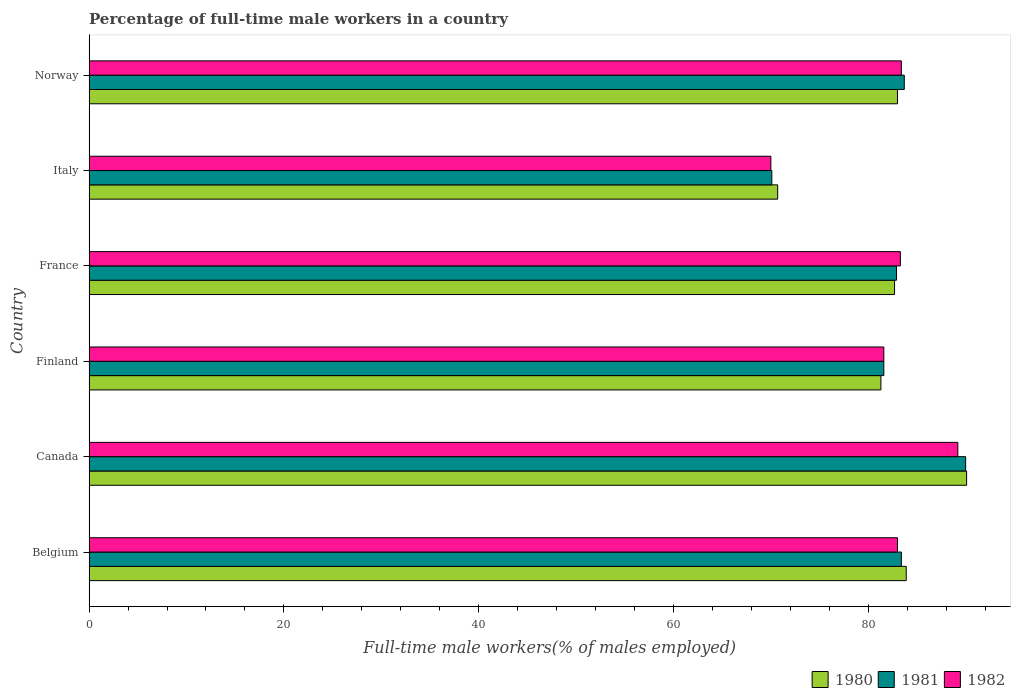How many groups of bars are there?
Give a very brief answer. 6. Are the number of bars per tick equal to the number of legend labels?
Your answer should be very brief. Yes. How many bars are there on the 2nd tick from the top?
Provide a short and direct response. 3. How many bars are there on the 2nd tick from the bottom?
Your response must be concise. 3. What is the label of the 6th group of bars from the top?
Provide a succinct answer. Belgium. What is the percentage of full-time male workers in 1981 in Belgium?
Ensure brevity in your answer.  83.4. Across all countries, what is the maximum percentage of full-time male workers in 1982?
Provide a succinct answer. 89.2. Across all countries, what is the minimum percentage of full-time male workers in 1981?
Your answer should be very brief. 70.1. In which country was the percentage of full-time male workers in 1981 maximum?
Offer a very short reply. Canada. In which country was the percentage of full-time male workers in 1981 minimum?
Provide a short and direct response. Italy. What is the total percentage of full-time male workers in 1980 in the graph?
Provide a succinct answer. 491.7. What is the difference between the percentage of full-time male workers in 1982 in Italy and the percentage of full-time male workers in 1981 in Norway?
Offer a very short reply. -13.7. What is the average percentage of full-time male workers in 1982 per country?
Your answer should be very brief. 81.75. What is the difference between the percentage of full-time male workers in 1980 and percentage of full-time male workers in 1982 in Norway?
Ensure brevity in your answer.  -0.4. What is the ratio of the percentage of full-time male workers in 1982 in Belgium to that in Italy?
Your answer should be compact. 1.19. Is the percentage of full-time male workers in 1980 in Finland less than that in Italy?
Keep it short and to the point. No. Is the difference between the percentage of full-time male workers in 1980 in Canada and France greater than the difference between the percentage of full-time male workers in 1982 in Canada and France?
Make the answer very short. Yes. What is the difference between the highest and the second highest percentage of full-time male workers in 1980?
Provide a short and direct response. 6.2. What is the difference between the highest and the lowest percentage of full-time male workers in 1980?
Provide a succinct answer. 19.4. Is the sum of the percentage of full-time male workers in 1982 in Belgium and Finland greater than the maximum percentage of full-time male workers in 1980 across all countries?
Provide a short and direct response. Yes. What does the 1st bar from the top in Italy represents?
Provide a succinct answer. 1982. Is it the case that in every country, the sum of the percentage of full-time male workers in 1980 and percentage of full-time male workers in 1982 is greater than the percentage of full-time male workers in 1981?
Your answer should be very brief. Yes. How many bars are there?
Provide a short and direct response. 18. What is the difference between two consecutive major ticks on the X-axis?
Ensure brevity in your answer.  20. How many legend labels are there?
Your response must be concise. 3. What is the title of the graph?
Keep it short and to the point. Percentage of full-time male workers in a country. What is the label or title of the X-axis?
Your response must be concise. Full-time male workers(% of males employed). What is the Full-time male workers(% of males employed) in 1980 in Belgium?
Ensure brevity in your answer.  83.9. What is the Full-time male workers(% of males employed) of 1981 in Belgium?
Your answer should be very brief. 83.4. What is the Full-time male workers(% of males employed) of 1980 in Canada?
Keep it short and to the point. 90.1. What is the Full-time male workers(% of males employed) of 1982 in Canada?
Keep it short and to the point. 89.2. What is the Full-time male workers(% of males employed) in 1980 in Finland?
Provide a succinct answer. 81.3. What is the Full-time male workers(% of males employed) in 1981 in Finland?
Ensure brevity in your answer.  81.6. What is the Full-time male workers(% of males employed) in 1982 in Finland?
Your answer should be compact. 81.6. What is the Full-time male workers(% of males employed) in 1980 in France?
Ensure brevity in your answer.  82.7. What is the Full-time male workers(% of males employed) of 1981 in France?
Offer a terse response. 82.9. What is the Full-time male workers(% of males employed) in 1982 in France?
Your answer should be compact. 83.3. What is the Full-time male workers(% of males employed) of 1980 in Italy?
Give a very brief answer. 70.7. What is the Full-time male workers(% of males employed) of 1981 in Italy?
Make the answer very short. 70.1. What is the Full-time male workers(% of males employed) in 1982 in Italy?
Provide a short and direct response. 70. What is the Full-time male workers(% of males employed) of 1980 in Norway?
Give a very brief answer. 83. What is the Full-time male workers(% of males employed) of 1981 in Norway?
Provide a short and direct response. 83.7. What is the Full-time male workers(% of males employed) of 1982 in Norway?
Provide a short and direct response. 83.4. Across all countries, what is the maximum Full-time male workers(% of males employed) of 1980?
Your response must be concise. 90.1. Across all countries, what is the maximum Full-time male workers(% of males employed) in 1981?
Offer a very short reply. 90. Across all countries, what is the maximum Full-time male workers(% of males employed) of 1982?
Ensure brevity in your answer.  89.2. Across all countries, what is the minimum Full-time male workers(% of males employed) in 1980?
Keep it short and to the point. 70.7. Across all countries, what is the minimum Full-time male workers(% of males employed) of 1981?
Provide a short and direct response. 70.1. Across all countries, what is the minimum Full-time male workers(% of males employed) in 1982?
Your answer should be compact. 70. What is the total Full-time male workers(% of males employed) in 1980 in the graph?
Your answer should be compact. 491.7. What is the total Full-time male workers(% of males employed) of 1981 in the graph?
Give a very brief answer. 491.7. What is the total Full-time male workers(% of males employed) of 1982 in the graph?
Provide a succinct answer. 490.5. What is the difference between the Full-time male workers(% of males employed) in 1981 in Belgium and that in Canada?
Provide a succinct answer. -6.6. What is the difference between the Full-time male workers(% of males employed) of 1982 in Belgium and that in Canada?
Your answer should be compact. -6.2. What is the difference between the Full-time male workers(% of males employed) of 1981 in Belgium and that in Finland?
Your answer should be very brief. 1.8. What is the difference between the Full-time male workers(% of males employed) in 1982 in Belgium and that in Finland?
Offer a terse response. 1.4. What is the difference between the Full-time male workers(% of males employed) in 1981 in Belgium and that in France?
Ensure brevity in your answer.  0.5. What is the difference between the Full-time male workers(% of males employed) of 1981 in Belgium and that in Italy?
Keep it short and to the point. 13.3. What is the difference between the Full-time male workers(% of males employed) in 1982 in Belgium and that in Italy?
Your answer should be very brief. 13. What is the difference between the Full-time male workers(% of males employed) in 1980 in Belgium and that in Norway?
Keep it short and to the point. 0.9. What is the difference between the Full-time male workers(% of males employed) of 1981 in Belgium and that in Norway?
Keep it short and to the point. -0.3. What is the difference between the Full-time male workers(% of males employed) of 1982 in Belgium and that in Norway?
Your response must be concise. -0.4. What is the difference between the Full-time male workers(% of males employed) in 1981 in Canada and that in Finland?
Provide a short and direct response. 8.4. What is the difference between the Full-time male workers(% of males employed) in 1981 in Canada and that in France?
Provide a succinct answer. 7.1. What is the difference between the Full-time male workers(% of males employed) of 1980 in Canada and that in Italy?
Your answer should be compact. 19.4. What is the difference between the Full-time male workers(% of males employed) of 1981 in Canada and that in Italy?
Your answer should be compact. 19.9. What is the difference between the Full-time male workers(% of males employed) of 1980 in Canada and that in Norway?
Offer a terse response. 7.1. What is the difference between the Full-time male workers(% of males employed) in 1982 in Canada and that in Norway?
Provide a succinct answer. 5.8. What is the difference between the Full-time male workers(% of males employed) in 1981 in Finland and that in France?
Your answer should be compact. -1.3. What is the difference between the Full-time male workers(% of males employed) of 1982 in Finland and that in France?
Keep it short and to the point. -1.7. What is the difference between the Full-time male workers(% of males employed) in 1981 in Finland and that in Italy?
Offer a very short reply. 11.5. What is the difference between the Full-time male workers(% of males employed) of 1980 in Finland and that in Norway?
Your answer should be very brief. -1.7. What is the difference between the Full-time male workers(% of males employed) in 1982 in Finland and that in Norway?
Your response must be concise. -1.8. What is the difference between the Full-time male workers(% of males employed) of 1980 in France and that in Italy?
Make the answer very short. 12. What is the difference between the Full-time male workers(% of males employed) of 1980 in France and that in Norway?
Offer a very short reply. -0.3. What is the difference between the Full-time male workers(% of males employed) in 1981 in France and that in Norway?
Your answer should be very brief. -0.8. What is the difference between the Full-time male workers(% of males employed) in 1982 in France and that in Norway?
Give a very brief answer. -0.1. What is the difference between the Full-time male workers(% of males employed) of 1980 in Italy and that in Norway?
Offer a very short reply. -12.3. What is the difference between the Full-time male workers(% of males employed) of 1981 in Italy and that in Norway?
Offer a very short reply. -13.6. What is the difference between the Full-time male workers(% of males employed) in 1980 in Belgium and the Full-time male workers(% of males employed) in 1981 in Finland?
Your answer should be compact. 2.3. What is the difference between the Full-time male workers(% of males employed) in 1980 in Belgium and the Full-time male workers(% of males employed) in 1982 in Finland?
Your answer should be compact. 2.3. What is the difference between the Full-time male workers(% of males employed) of 1981 in Belgium and the Full-time male workers(% of males employed) of 1982 in Finland?
Your answer should be compact. 1.8. What is the difference between the Full-time male workers(% of males employed) of 1980 in Belgium and the Full-time male workers(% of males employed) of 1982 in France?
Provide a succinct answer. 0.6. What is the difference between the Full-time male workers(% of males employed) of 1981 in Belgium and the Full-time male workers(% of males employed) of 1982 in France?
Your response must be concise. 0.1. What is the difference between the Full-time male workers(% of males employed) in 1980 in Canada and the Full-time male workers(% of males employed) in 1981 in Finland?
Your response must be concise. 8.5. What is the difference between the Full-time male workers(% of males employed) in 1980 in Canada and the Full-time male workers(% of males employed) in 1982 in France?
Offer a terse response. 6.8. What is the difference between the Full-time male workers(% of males employed) in 1980 in Canada and the Full-time male workers(% of males employed) in 1982 in Italy?
Provide a succinct answer. 20.1. What is the difference between the Full-time male workers(% of males employed) in 1980 in Canada and the Full-time male workers(% of males employed) in 1981 in Norway?
Your response must be concise. 6.4. What is the difference between the Full-time male workers(% of males employed) in 1980 in Canada and the Full-time male workers(% of males employed) in 1982 in Norway?
Your response must be concise. 6.7. What is the difference between the Full-time male workers(% of males employed) in 1981 in Canada and the Full-time male workers(% of males employed) in 1982 in Norway?
Your response must be concise. 6.6. What is the difference between the Full-time male workers(% of males employed) of 1980 in Finland and the Full-time male workers(% of males employed) of 1981 in France?
Offer a terse response. -1.6. What is the difference between the Full-time male workers(% of males employed) of 1980 in Finland and the Full-time male workers(% of males employed) of 1982 in France?
Give a very brief answer. -2. What is the difference between the Full-time male workers(% of males employed) of 1980 in Finland and the Full-time male workers(% of males employed) of 1981 in Italy?
Your answer should be very brief. 11.2. What is the difference between the Full-time male workers(% of males employed) of 1980 in Finland and the Full-time male workers(% of males employed) of 1982 in Norway?
Offer a terse response. -2.1. What is the difference between the Full-time male workers(% of males employed) in 1981 in Finland and the Full-time male workers(% of males employed) in 1982 in Norway?
Provide a succinct answer. -1.8. What is the difference between the Full-time male workers(% of males employed) of 1980 in France and the Full-time male workers(% of males employed) of 1981 in Italy?
Provide a short and direct response. 12.6. What is the difference between the Full-time male workers(% of males employed) in 1980 in France and the Full-time male workers(% of males employed) in 1982 in Italy?
Provide a succinct answer. 12.7. What is the difference between the Full-time male workers(% of males employed) of 1981 in France and the Full-time male workers(% of males employed) of 1982 in Italy?
Your answer should be compact. 12.9. What is the difference between the Full-time male workers(% of males employed) of 1980 in France and the Full-time male workers(% of males employed) of 1982 in Norway?
Offer a terse response. -0.7. What is the difference between the Full-time male workers(% of males employed) of 1981 in France and the Full-time male workers(% of males employed) of 1982 in Norway?
Offer a very short reply. -0.5. What is the difference between the Full-time male workers(% of males employed) of 1980 in Italy and the Full-time male workers(% of males employed) of 1981 in Norway?
Ensure brevity in your answer.  -13. What is the difference between the Full-time male workers(% of males employed) in 1980 in Italy and the Full-time male workers(% of males employed) in 1982 in Norway?
Your response must be concise. -12.7. What is the average Full-time male workers(% of males employed) of 1980 per country?
Make the answer very short. 81.95. What is the average Full-time male workers(% of males employed) of 1981 per country?
Provide a short and direct response. 81.95. What is the average Full-time male workers(% of males employed) of 1982 per country?
Your answer should be very brief. 81.75. What is the difference between the Full-time male workers(% of males employed) of 1980 and Full-time male workers(% of males employed) of 1981 in Belgium?
Offer a very short reply. 0.5. What is the difference between the Full-time male workers(% of males employed) of 1980 and Full-time male workers(% of males employed) of 1982 in Belgium?
Provide a short and direct response. 0.9. What is the difference between the Full-time male workers(% of males employed) of 1980 and Full-time male workers(% of males employed) of 1981 in Canada?
Provide a short and direct response. 0.1. What is the difference between the Full-time male workers(% of males employed) in 1981 and Full-time male workers(% of males employed) in 1982 in Canada?
Provide a short and direct response. 0.8. What is the difference between the Full-time male workers(% of males employed) of 1980 and Full-time male workers(% of males employed) of 1982 in Finland?
Give a very brief answer. -0.3. What is the difference between the Full-time male workers(% of males employed) in 1981 and Full-time male workers(% of males employed) in 1982 in Finland?
Offer a terse response. 0. What is the difference between the Full-time male workers(% of males employed) in 1980 and Full-time male workers(% of males employed) in 1981 in Italy?
Provide a succinct answer. 0.6. What is the difference between the Full-time male workers(% of males employed) in 1980 and Full-time male workers(% of males employed) in 1981 in Norway?
Keep it short and to the point. -0.7. What is the difference between the Full-time male workers(% of males employed) in 1980 and Full-time male workers(% of males employed) in 1982 in Norway?
Provide a short and direct response. -0.4. What is the difference between the Full-time male workers(% of males employed) in 1981 and Full-time male workers(% of males employed) in 1982 in Norway?
Your answer should be very brief. 0.3. What is the ratio of the Full-time male workers(% of males employed) of 1980 in Belgium to that in Canada?
Make the answer very short. 0.93. What is the ratio of the Full-time male workers(% of males employed) of 1981 in Belgium to that in Canada?
Offer a terse response. 0.93. What is the ratio of the Full-time male workers(% of males employed) of 1982 in Belgium to that in Canada?
Provide a succinct answer. 0.93. What is the ratio of the Full-time male workers(% of males employed) in 1980 in Belgium to that in Finland?
Offer a terse response. 1.03. What is the ratio of the Full-time male workers(% of males employed) in 1981 in Belgium to that in Finland?
Your answer should be very brief. 1.02. What is the ratio of the Full-time male workers(% of males employed) of 1982 in Belgium to that in Finland?
Give a very brief answer. 1.02. What is the ratio of the Full-time male workers(% of males employed) in 1980 in Belgium to that in France?
Your answer should be compact. 1.01. What is the ratio of the Full-time male workers(% of males employed) in 1981 in Belgium to that in France?
Your answer should be compact. 1.01. What is the ratio of the Full-time male workers(% of males employed) of 1980 in Belgium to that in Italy?
Offer a very short reply. 1.19. What is the ratio of the Full-time male workers(% of males employed) in 1981 in Belgium to that in Italy?
Provide a succinct answer. 1.19. What is the ratio of the Full-time male workers(% of males employed) of 1982 in Belgium to that in Italy?
Give a very brief answer. 1.19. What is the ratio of the Full-time male workers(% of males employed) in 1980 in Belgium to that in Norway?
Your answer should be very brief. 1.01. What is the ratio of the Full-time male workers(% of males employed) in 1980 in Canada to that in Finland?
Keep it short and to the point. 1.11. What is the ratio of the Full-time male workers(% of males employed) in 1981 in Canada to that in Finland?
Give a very brief answer. 1.1. What is the ratio of the Full-time male workers(% of males employed) in 1982 in Canada to that in Finland?
Provide a short and direct response. 1.09. What is the ratio of the Full-time male workers(% of males employed) of 1980 in Canada to that in France?
Keep it short and to the point. 1.09. What is the ratio of the Full-time male workers(% of males employed) in 1981 in Canada to that in France?
Offer a terse response. 1.09. What is the ratio of the Full-time male workers(% of males employed) in 1982 in Canada to that in France?
Your answer should be very brief. 1.07. What is the ratio of the Full-time male workers(% of males employed) in 1980 in Canada to that in Italy?
Your response must be concise. 1.27. What is the ratio of the Full-time male workers(% of males employed) in 1981 in Canada to that in Italy?
Ensure brevity in your answer.  1.28. What is the ratio of the Full-time male workers(% of males employed) of 1982 in Canada to that in Italy?
Make the answer very short. 1.27. What is the ratio of the Full-time male workers(% of males employed) in 1980 in Canada to that in Norway?
Your answer should be compact. 1.09. What is the ratio of the Full-time male workers(% of males employed) in 1981 in Canada to that in Norway?
Keep it short and to the point. 1.08. What is the ratio of the Full-time male workers(% of males employed) in 1982 in Canada to that in Norway?
Offer a very short reply. 1.07. What is the ratio of the Full-time male workers(% of males employed) of 1980 in Finland to that in France?
Give a very brief answer. 0.98. What is the ratio of the Full-time male workers(% of males employed) of 1981 in Finland to that in France?
Your response must be concise. 0.98. What is the ratio of the Full-time male workers(% of males employed) in 1982 in Finland to that in France?
Keep it short and to the point. 0.98. What is the ratio of the Full-time male workers(% of males employed) in 1980 in Finland to that in Italy?
Your answer should be compact. 1.15. What is the ratio of the Full-time male workers(% of males employed) in 1981 in Finland to that in Italy?
Ensure brevity in your answer.  1.16. What is the ratio of the Full-time male workers(% of males employed) in 1982 in Finland to that in Italy?
Provide a short and direct response. 1.17. What is the ratio of the Full-time male workers(% of males employed) of 1980 in Finland to that in Norway?
Ensure brevity in your answer.  0.98. What is the ratio of the Full-time male workers(% of males employed) of 1981 in Finland to that in Norway?
Give a very brief answer. 0.97. What is the ratio of the Full-time male workers(% of males employed) in 1982 in Finland to that in Norway?
Keep it short and to the point. 0.98. What is the ratio of the Full-time male workers(% of males employed) of 1980 in France to that in Italy?
Offer a terse response. 1.17. What is the ratio of the Full-time male workers(% of males employed) of 1981 in France to that in Italy?
Offer a terse response. 1.18. What is the ratio of the Full-time male workers(% of males employed) in 1982 in France to that in Italy?
Give a very brief answer. 1.19. What is the ratio of the Full-time male workers(% of males employed) of 1981 in France to that in Norway?
Keep it short and to the point. 0.99. What is the ratio of the Full-time male workers(% of males employed) of 1982 in France to that in Norway?
Keep it short and to the point. 1. What is the ratio of the Full-time male workers(% of males employed) of 1980 in Italy to that in Norway?
Your response must be concise. 0.85. What is the ratio of the Full-time male workers(% of males employed) in 1981 in Italy to that in Norway?
Keep it short and to the point. 0.84. What is the ratio of the Full-time male workers(% of males employed) in 1982 in Italy to that in Norway?
Provide a short and direct response. 0.84. What is the difference between the highest and the second highest Full-time male workers(% of males employed) in 1980?
Your answer should be very brief. 6.2. What is the difference between the highest and the second highest Full-time male workers(% of males employed) in 1981?
Your response must be concise. 6.3. What is the difference between the highest and the lowest Full-time male workers(% of males employed) of 1980?
Keep it short and to the point. 19.4. What is the difference between the highest and the lowest Full-time male workers(% of males employed) in 1981?
Offer a terse response. 19.9. 